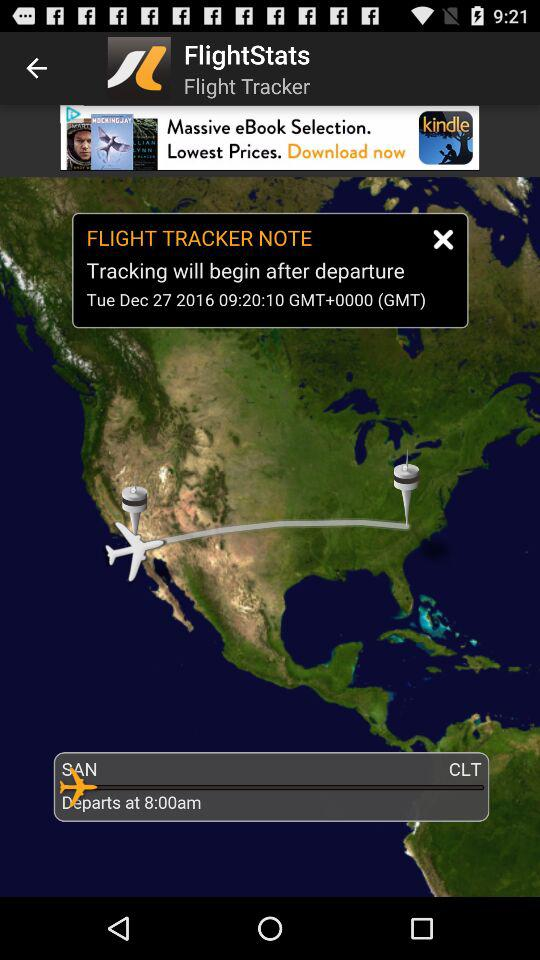What is the destination Location?
When the provided information is insufficient, respond with <no answer>. <no answer> 